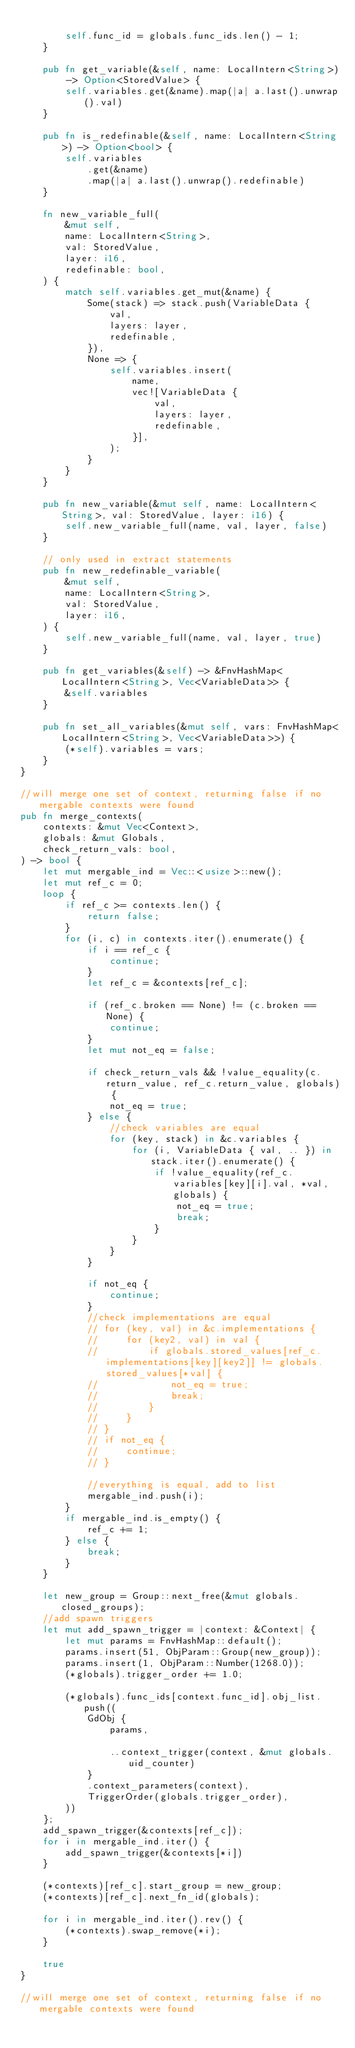Convert code to text. <code><loc_0><loc_0><loc_500><loc_500><_Rust_>
        self.func_id = globals.func_ids.len() - 1;
    }

    pub fn get_variable(&self, name: LocalIntern<String>) -> Option<StoredValue> {
        self.variables.get(&name).map(|a| a.last().unwrap().val)
    }

    pub fn is_redefinable(&self, name: LocalIntern<String>) -> Option<bool> {
        self.variables
            .get(&name)
            .map(|a| a.last().unwrap().redefinable)
    }

    fn new_variable_full(
        &mut self,
        name: LocalIntern<String>,
        val: StoredValue,
        layer: i16,
        redefinable: bool,
    ) {
        match self.variables.get_mut(&name) {
            Some(stack) => stack.push(VariableData {
                val,
                layers: layer,
                redefinable,
            }),
            None => {
                self.variables.insert(
                    name,
                    vec![VariableData {
                        val,
                        layers: layer,
                        redefinable,
                    }],
                );
            }
        }
    }

    pub fn new_variable(&mut self, name: LocalIntern<String>, val: StoredValue, layer: i16) {
        self.new_variable_full(name, val, layer, false)
    }

    // only used in extract statements
    pub fn new_redefinable_variable(
        &mut self,
        name: LocalIntern<String>,
        val: StoredValue,
        layer: i16,
    ) {
        self.new_variable_full(name, val, layer, true)
    }

    pub fn get_variables(&self) -> &FnvHashMap<LocalIntern<String>, Vec<VariableData>> {
        &self.variables
    }

    pub fn set_all_variables(&mut self, vars: FnvHashMap<LocalIntern<String>, Vec<VariableData>>) {
        (*self).variables = vars;
    }
}

//will merge one set of context, returning false if no mergable contexts were found
pub fn merge_contexts(
    contexts: &mut Vec<Context>,
    globals: &mut Globals,
    check_return_vals: bool,
) -> bool {
    let mut mergable_ind = Vec::<usize>::new();
    let mut ref_c = 0;
    loop {
        if ref_c >= contexts.len() {
            return false;
        }
        for (i, c) in contexts.iter().enumerate() {
            if i == ref_c {
                continue;
            }
            let ref_c = &contexts[ref_c];

            if (ref_c.broken == None) != (c.broken == None) {
                continue;
            }
            let mut not_eq = false;

            if check_return_vals && !value_equality(c.return_value, ref_c.return_value, globals) {
                not_eq = true;
            } else {
                //check variables are equal
                for (key, stack) in &c.variables {
                    for (i, VariableData { val, .. }) in stack.iter().enumerate() {
                        if !value_equality(ref_c.variables[key][i].val, *val, globals) {
                            not_eq = true;
                            break;
                        }
                    }
                }
            }

            if not_eq {
                continue;
            }
            //check implementations are equal
            // for (key, val) in &c.implementations {
            //     for (key2, val) in val {
            //         if globals.stored_values[ref_c.implementations[key][key2]] != globals.stored_values[*val] {
            //             not_eq = true;
            //             break;
            //         }
            //     }
            // }
            // if not_eq {
            //     continue;
            // }

            //everything is equal, add to list
            mergable_ind.push(i);
        }
        if mergable_ind.is_empty() {
            ref_c += 1;
        } else {
            break;
        }
    }

    let new_group = Group::next_free(&mut globals.closed_groups);
    //add spawn triggers
    let mut add_spawn_trigger = |context: &Context| {
        let mut params = FnvHashMap::default();
        params.insert(51, ObjParam::Group(new_group));
        params.insert(1, ObjParam::Number(1268.0));
        (*globals).trigger_order += 1.0;

        (*globals).func_ids[context.func_id].obj_list.push((
            GdObj {
                params,

                ..context_trigger(context, &mut globals.uid_counter)
            }
            .context_parameters(context),
            TriggerOrder(globals.trigger_order),
        ))
    };
    add_spawn_trigger(&contexts[ref_c]);
    for i in mergable_ind.iter() {
        add_spawn_trigger(&contexts[*i])
    }

    (*contexts)[ref_c].start_group = new_group;
    (*contexts)[ref_c].next_fn_id(globals);

    for i in mergable_ind.iter().rev() {
        (*contexts).swap_remove(*i);
    }

    true
}

//will merge one set of context, returning false if no mergable contexts were found
</code> 